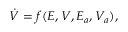Convert formula to latex. <formula><loc_0><loc_0><loc_500><loc_500>\begin{array} { r } { \dot { V } = f ( E , V , E _ { a } , V _ { a } ) , } \end{array}</formula> 